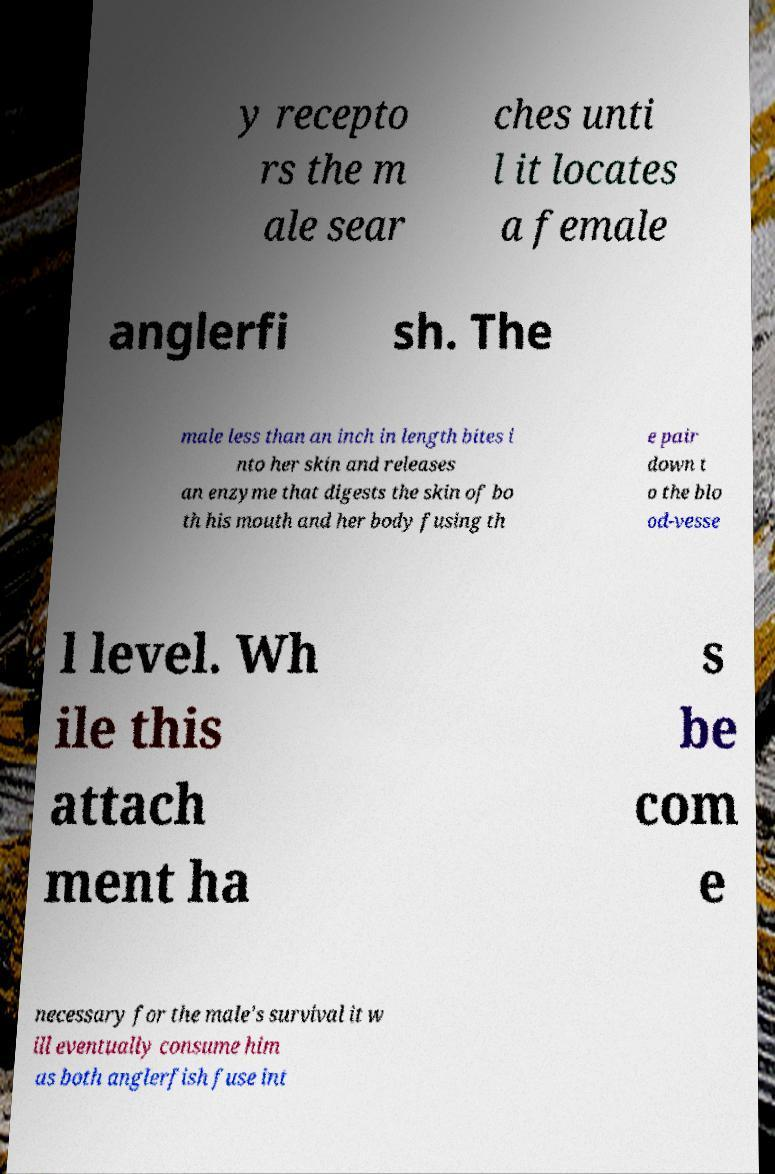Can you read and provide the text displayed in the image?This photo seems to have some interesting text. Can you extract and type it out for me? y recepto rs the m ale sear ches unti l it locates a female anglerfi sh. The male less than an inch in length bites i nto her skin and releases an enzyme that digests the skin of bo th his mouth and her body fusing th e pair down t o the blo od-vesse l level. Wh ile this attach ment ha s be com e necessary for the male's survival it w ill eventually consume him as both anglerfish fuse int 